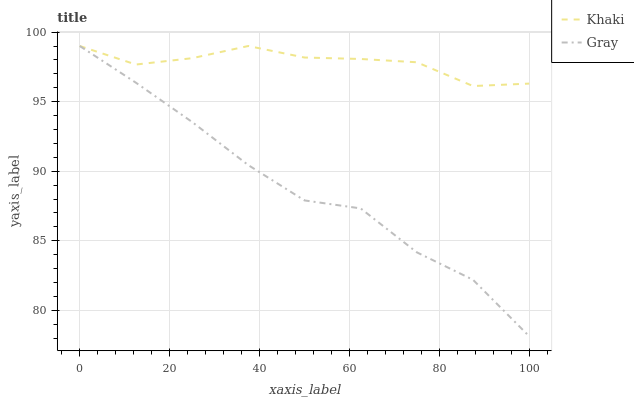Does Gray have the minimum area under the curve?
Answer yes or no. Yes. Does Khaki have the maximum area under the curve?
Answer yes or no. Yes. Does Khaki have the minimum area under the curve?
Answer yes or no. No. Is Khaki the smoothest?
Answer yes or no. Yes. Is Gray the roughest?
Answer yes or no. Yes. Is Khaki the roughest?
Answer yes or no. No. Does Gray have the lowest value?
Answer yes or no. Yes. Does Khaki have the lowest value?
Answer yes or no. No. Does Khaki have the highest value?
Answer yes or no. Yes. Does Khaki intersect Gray?
Answer yes or no. Yes. Is Khaki less than Gray?
Answer yes or no. No. Is Khaki greater than Gray?
Answer yes or no. No. 